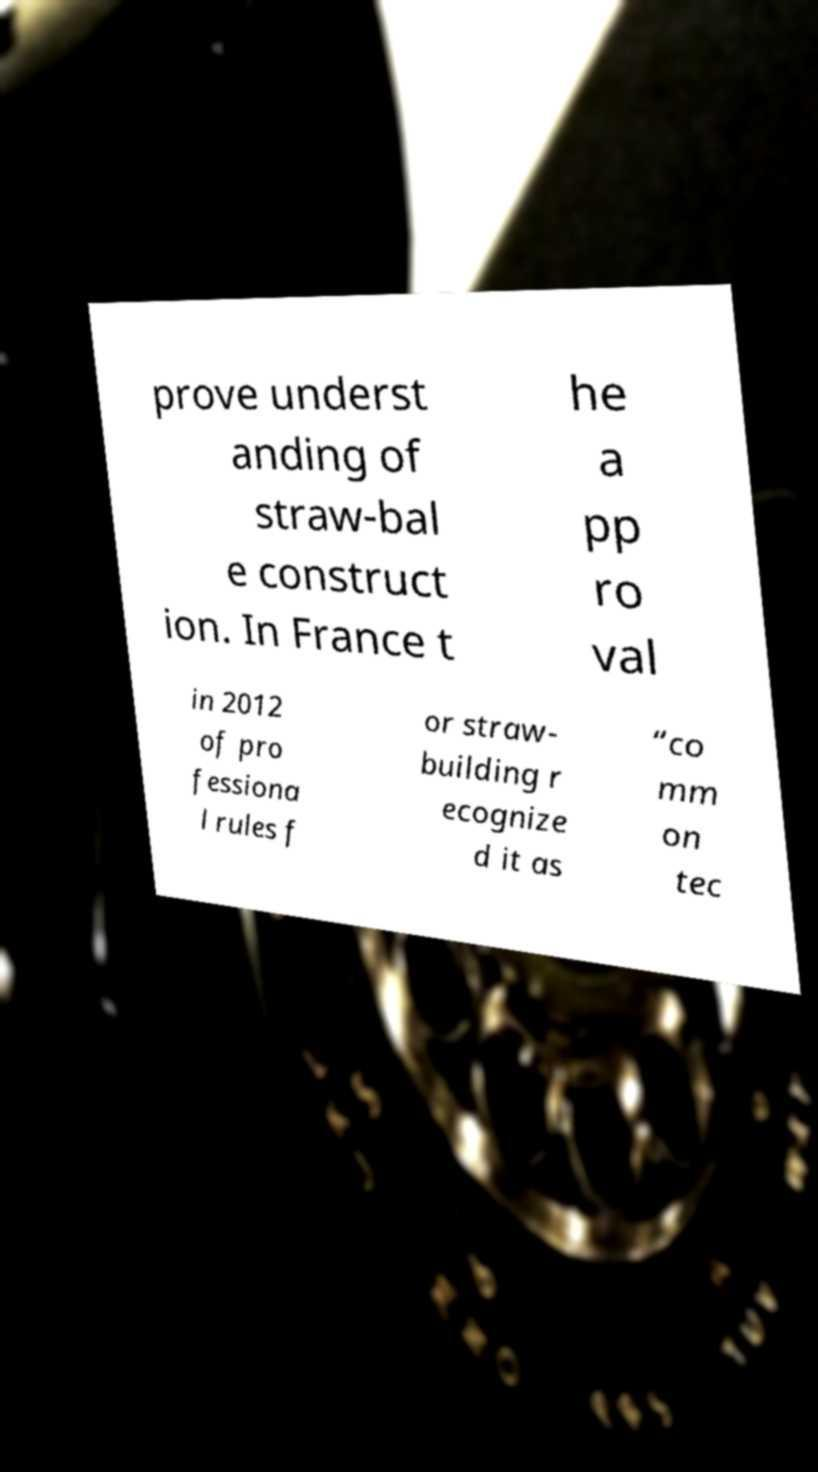Could you assist in decoding the text presented in this image and type it out clearly? prove underst anding of straw-bal e construct ion. In France t he a pp ro val in 2012 of pro fessiona l rules f or straw- building r ecognize d it as “co mm on tec 